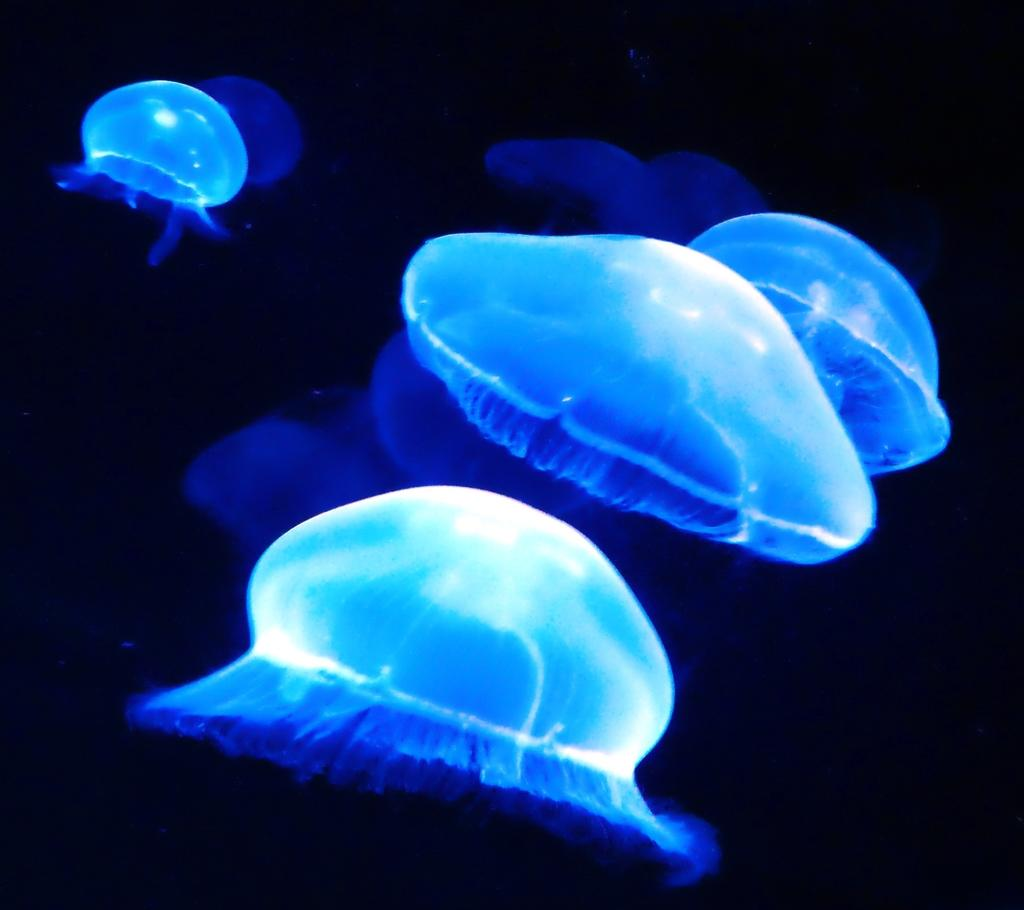What type of sea creatures are in the image? There are jellyfishes in the image. What color are the jellyfishes? The jellyfishes are blue in color. What is the color of the background in the image? The background of the image is black. Where might this image have been taken? The image might have been taken in an aquarium. Can you see a monkey moving around in the image? No, there is no monkey present in the image. What type of boot is visible in the image? There is no boot present in the image. 